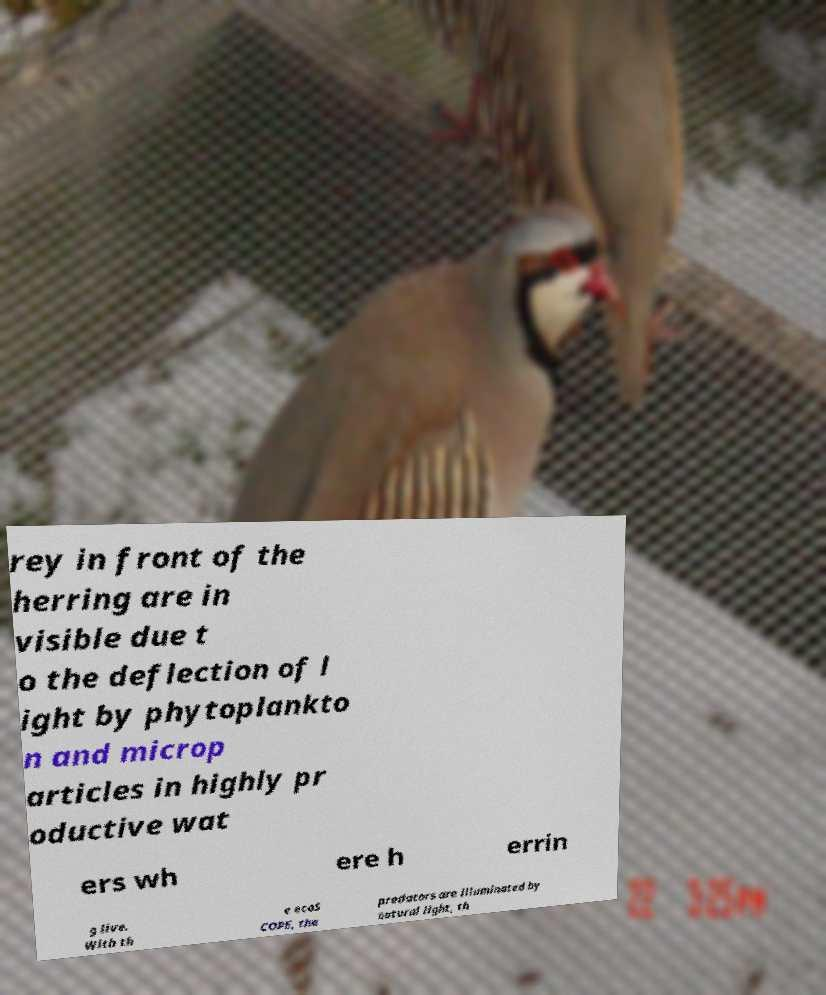Can you accurately transcribe the text from the provided image for me? rey in front of the herring are in visible due t o the deflection of l ight by phytoplankto n and microp articles in highly pr oductive wat ers wh ere h errin g live. With th e ecoS COPE, the predators are illuminated by natural light, th 